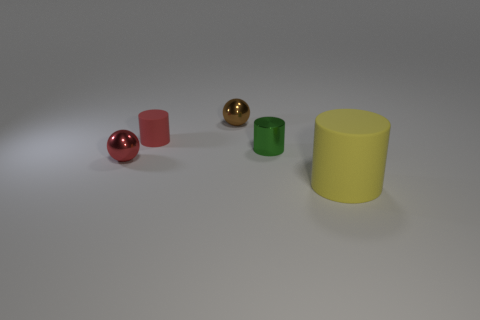Subtract all small matte cylinders. How many cylinders are left? 2 Add 3 large brown rubber blocks. How many objects exist? 8 Subtract all spheres. How many objects are left? 3 Add 2 red rubber things. How many red rubber things exist? 3 Subtract 0 blue cylinders. How many objects are left? 5 Subtract all metallic cylinders. Subtract all red rubber objects. How many objects are left? 3 Add 4 large rubber cylinders. How many large rubber cylinders are left? 5 